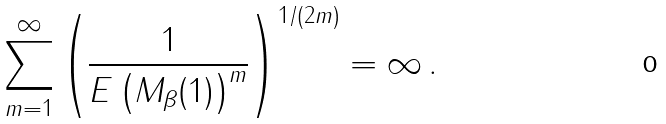<formula> <loc_0><loc_0><loc_500><loc_500>\sum _ { m = 1 } ^ { \infty } \left ( \frac { 1 } { E \left ( M _ { \beta } ( 1 ) \right ) ^ { m } } \right ) ^ { 1 / ( 2 m ) } = \infty \, .</formula> 